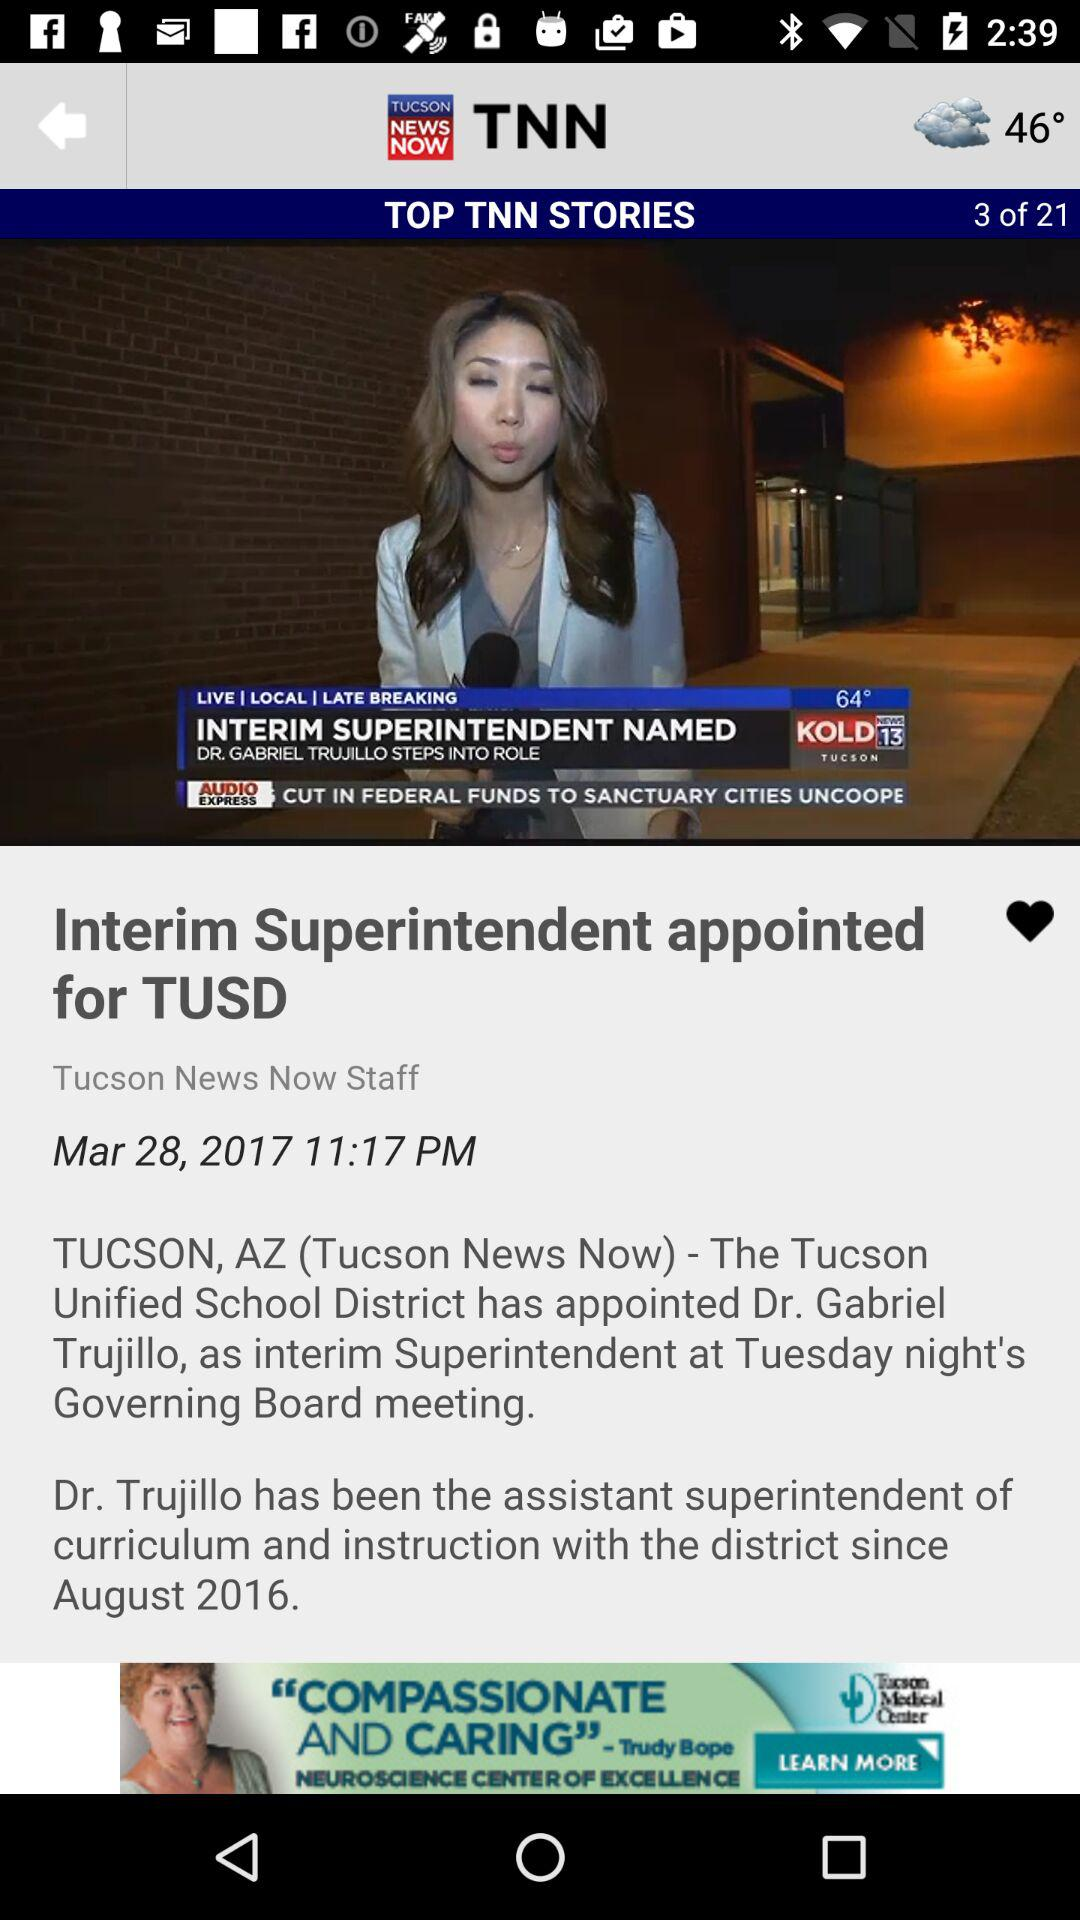What is the headline of the news? The headline of the news is "Interim Superintendent appointed for TUSD". 